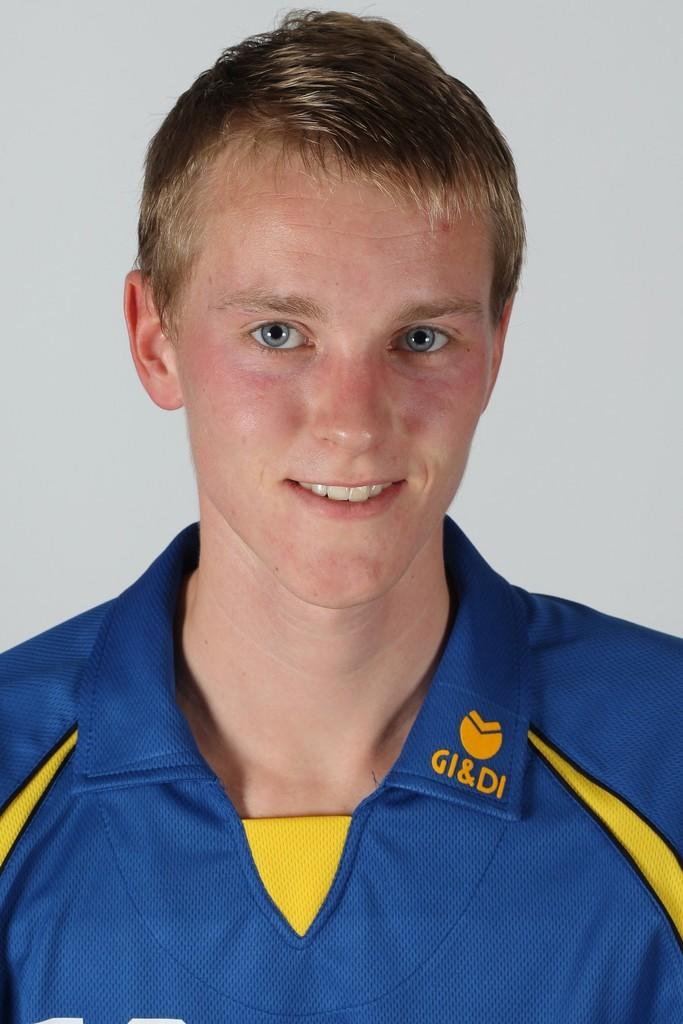<image>
Relay a brief, clear account of the picture shown. a young man wearing a collered shirt made by GI & DI 